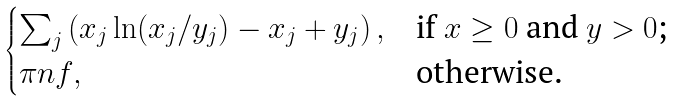Convert formula to latex. <formula><loc_0><loc_0><loc_500><loc_500>\begin{cases} \sum _ { j } \left ( x _ { j } \ln ( x _ { j } / y _ { j } ) - x _ { j } + y _ { j } \right ) , & \text {if $x\geq 0$ and $y>0$;} \\ \pi n f , & \text {otherwise.} \end{cases}</formula> 